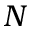Convert formula to latex. <formula><loc_0><loc_0><loc_500><loc_500>N</formula> 